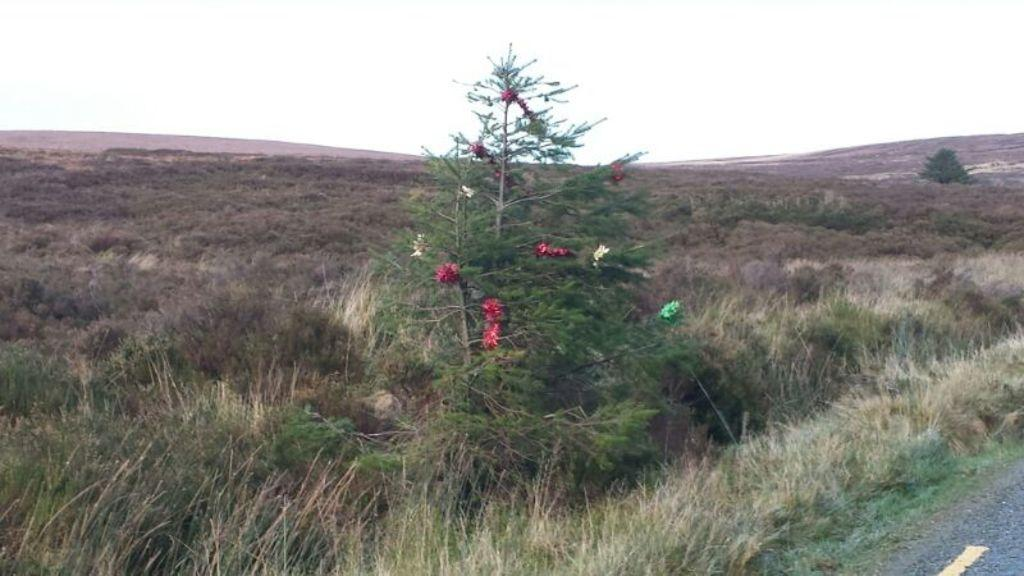What is hanging on the tree in the image? There are multi-color objects on the tree. What type of natural elements can be seen in the image? There are plants and trees in the image. What is the color of the plants and trees? The plants and trees are green in color. What can be seen in the background of the image? The sky in the background is white. Can you suggest a way to brush the rabbits in the image? There are no rabbits present in the image, so there is no need to brush them. 